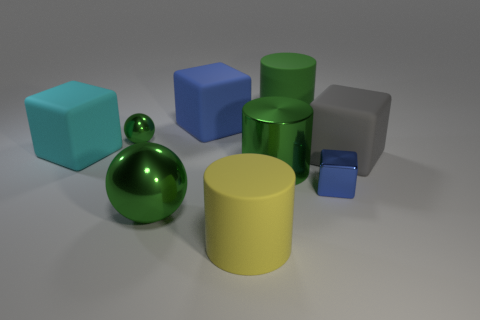Are there fewer big gray rubber things than small cyan cylinders?
Provide a succinct answer. No. There is a blue thing that is on the right side of the matte cylinder in front of the cyan object; what is its material?
Provide a succinct answer. Metal. Do the blue rubber thing and the metal cube have the same size?
Give a very brief answer. No. What number of objects are brown rubber cubes or tiny things?
Give a very brief answer. 2. What is the size of the green thing that is right of the big green shiny ball and behind the gray cube?
Make the answer very short. Large. Is the number of large gray rubber cubes that are on the left side of the big yellow rubber cylinder less than the number of tiny yellow metallic cylinders?
Your response must be concise. No. There is a big cyan thing that is the same material as the big blue block; what is its shape?
Ensure brevity in your answer.  Cube. Do the tiny metallic thing that is to the left of the big green rubber thing and the small shiny thing that is in front of the metal cylinder have the same shape?
Your response must be concise. No. Are there fewer yellow matte things that are behind the gray rubber block than small blue things that are to the right of the blue shiny object?
Offer a very short reply. No. What is the shape of the rubber object that is the same color as the big ball?
Provide a short and direct response. Cylinder. 